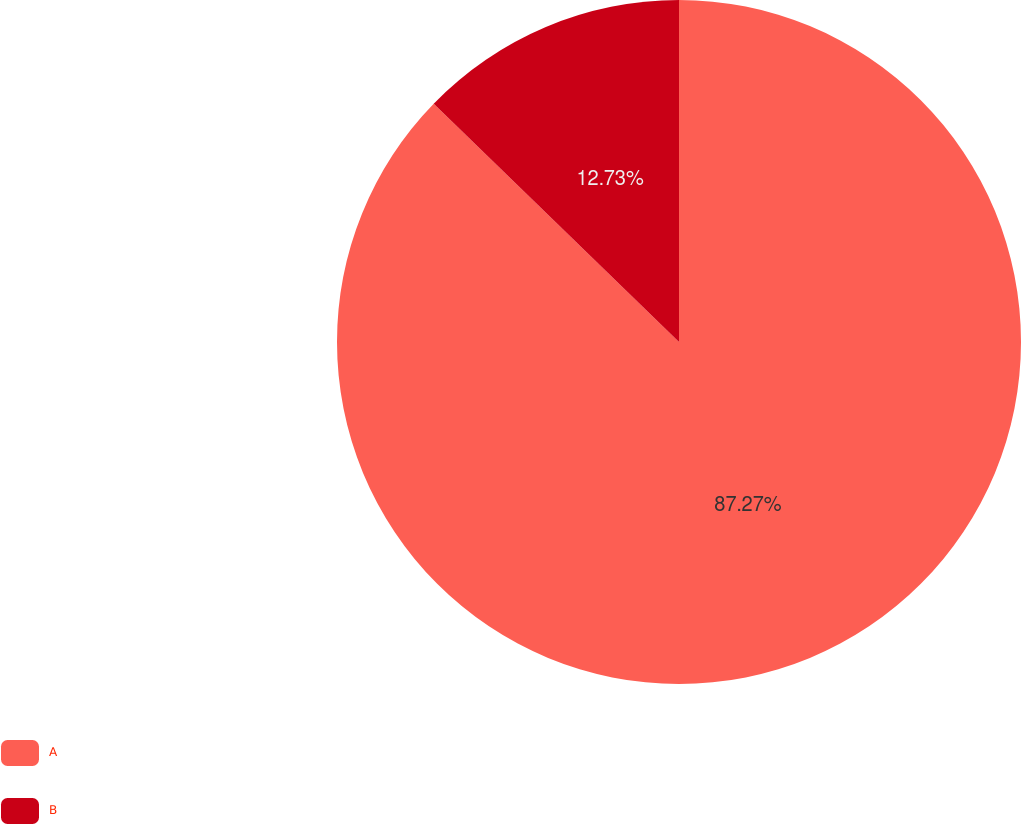Convert chart. <chart><loc_0><loc_0><loc_500><loc_500><pie_chart><fcel>A<fcel>B<nl><fcel>87.27%<fcel>12.73%<nl></chart> 